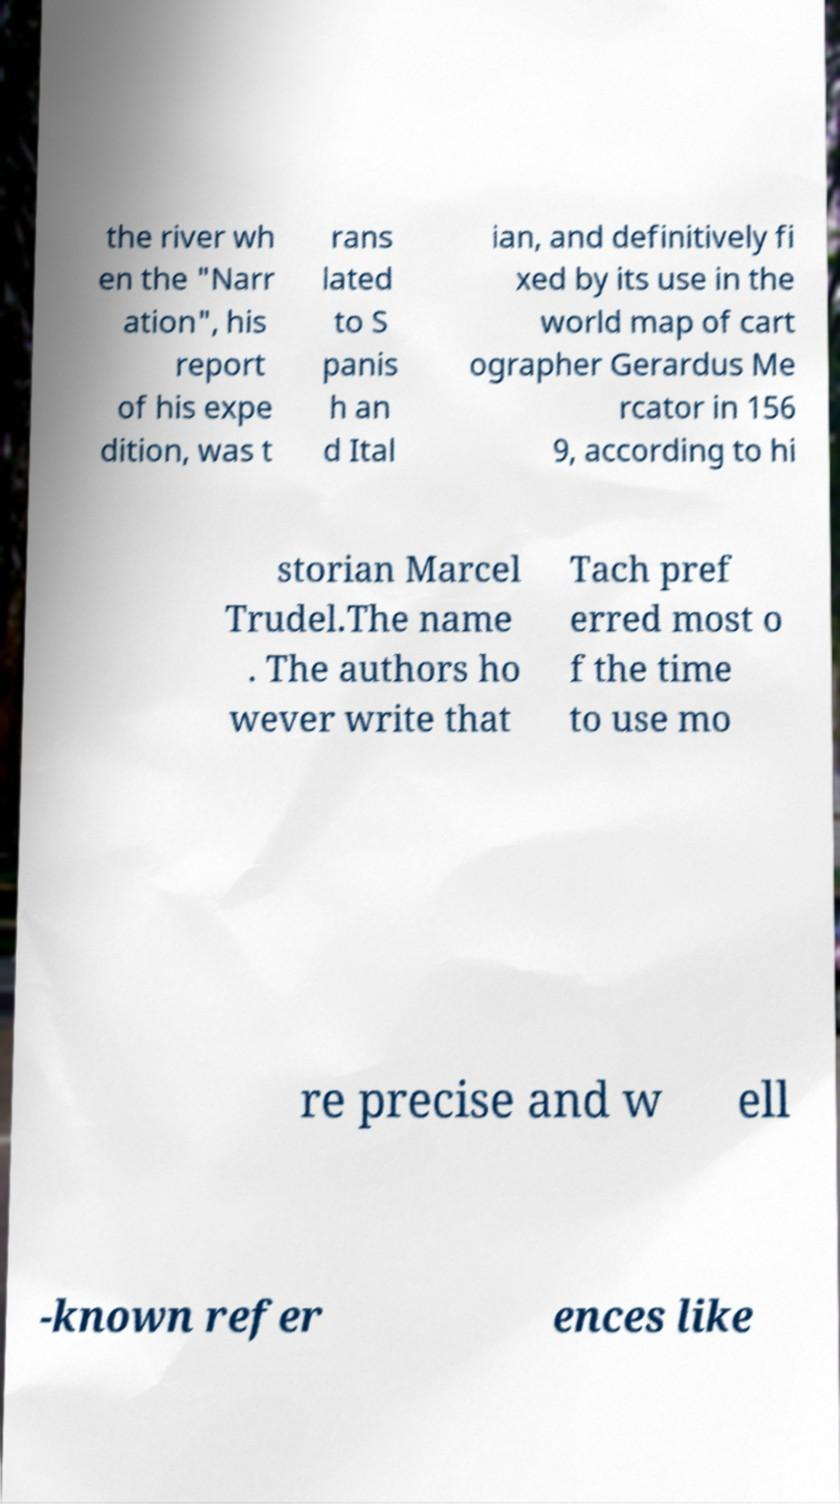Please identify and transcribe the text found in this image. the river wh en the "Narr ation", his report of his expe dition, was t rans lated to S panis h an d Ital ian, and definitively fi xed by its use in the world map of cart ographer Gerardus Me rcator in 156 9, according to hi storian Marcel Trudel.The name . The authors ho wever write that Tach pref erred most o f the time to use mo re precise and w ell -known refer ences like 